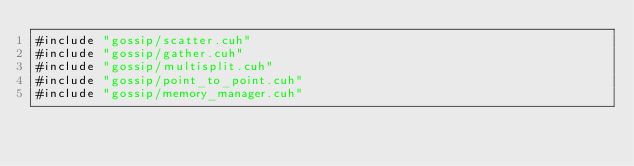<code> <loc_0><loc_0><loc_500><loc_500><_Cuda_>#include "gossip/scatter.cuh"
#include "gossip/gather.cuh"
#include "gossip/multisplit.cuh"
#include "gossip/point_to_point.cuh"
#include "gossip/memory_manager.cuh"
</code> 